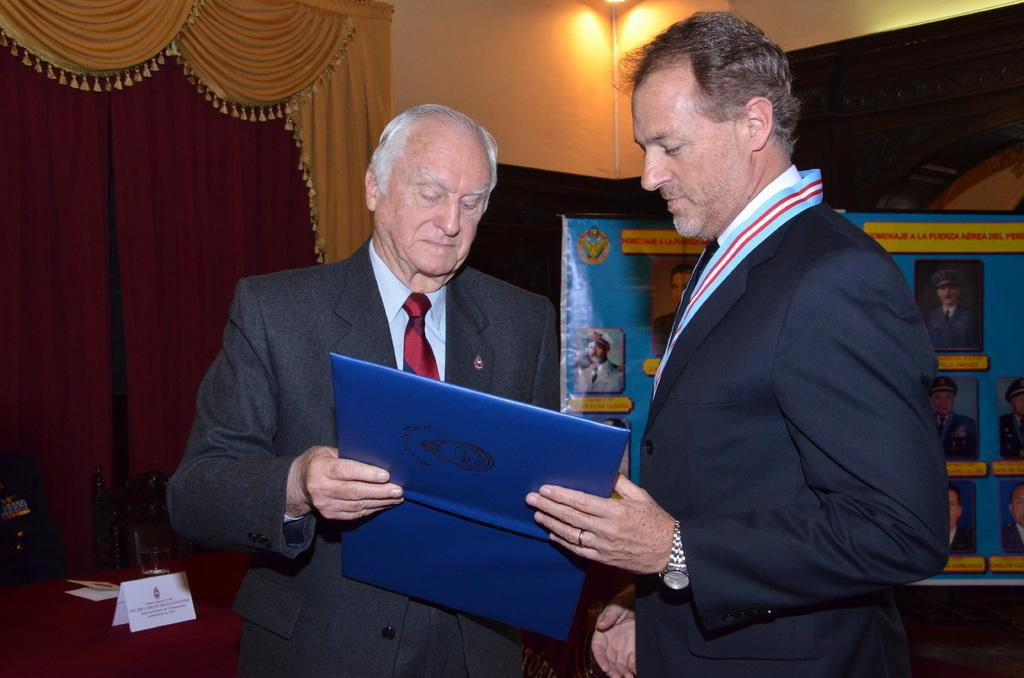How many people are present in the image? There are two persons in the image. What are the two persons holding? The two persons are holding a book. What can be seen in the image besides the people and the book? There is a curtain, a card, and posters in the image. What is visible in the background of the image? There is a wall and lights in the background of the image. What type of produce can be seen growing on the wall in the image? There is no produce visible in the image, and the wall does not have any plants or produce growing on it. 